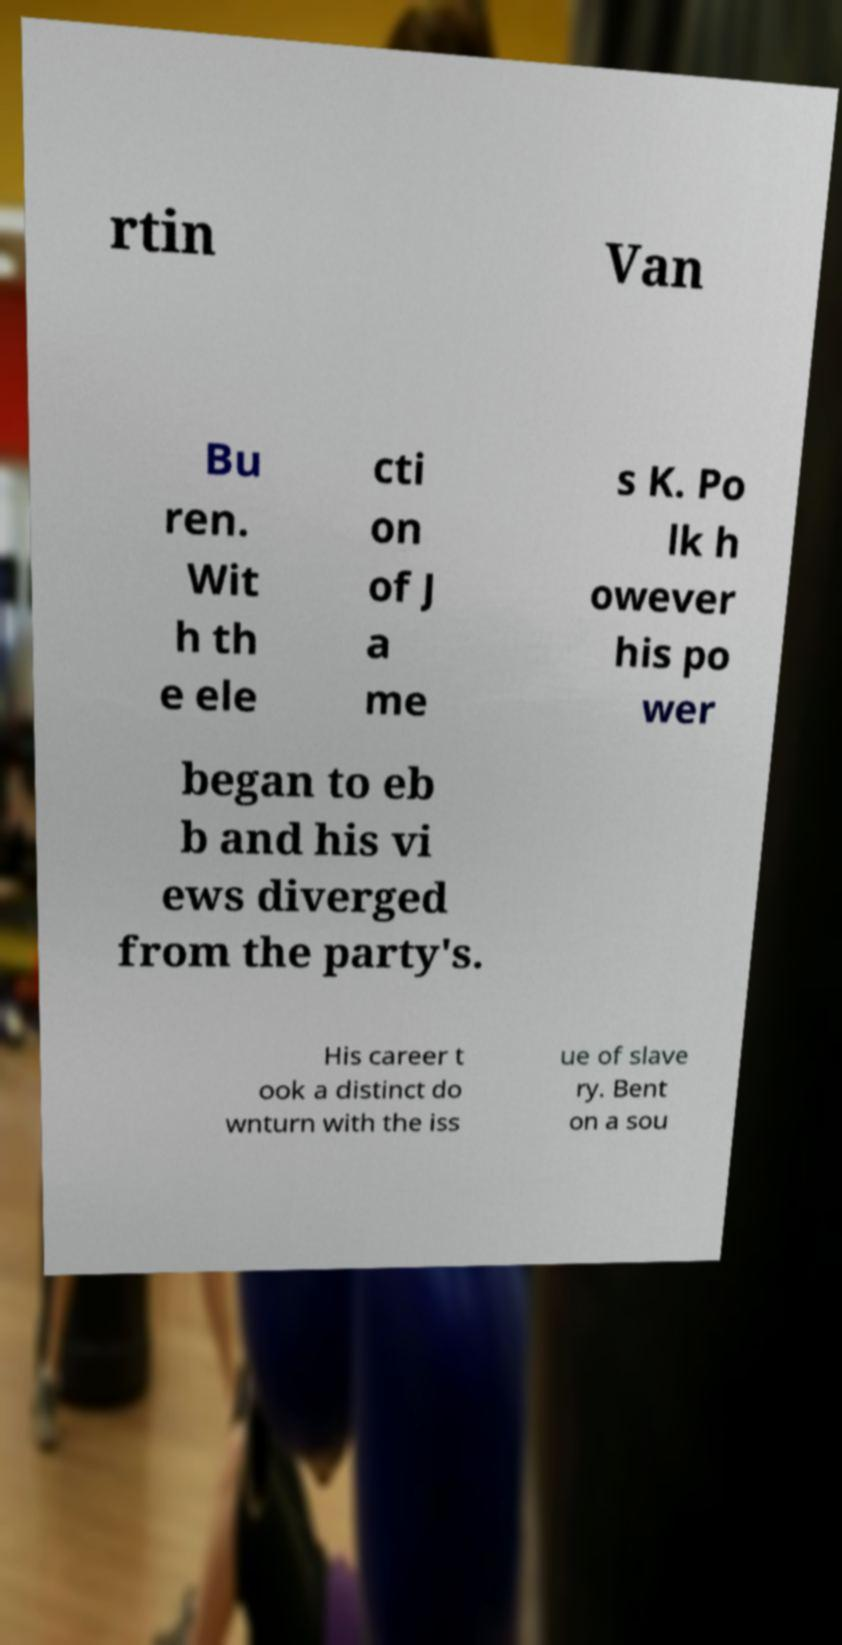I need the written content from this picture converted into text. Can you do that? rtin Van Bu ren. Wit h th e ele cti on of J a me s K. Po lk h owever his po wer began to eb b and his vi ews diverged from the party's. His career t ook a distinct do wnturn with the iss ue of slave ry. Bent on a sou 